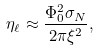Convert formula to latex. <formula><loc_0><loc_0><loc_500><loc_500>\eta _ { \ell } \approx \frac { \Phi _ { 0 } ^ { 2 } \sigma _ { N } } { 2 \pi \xi ^ { 2 } } ,</formula> 